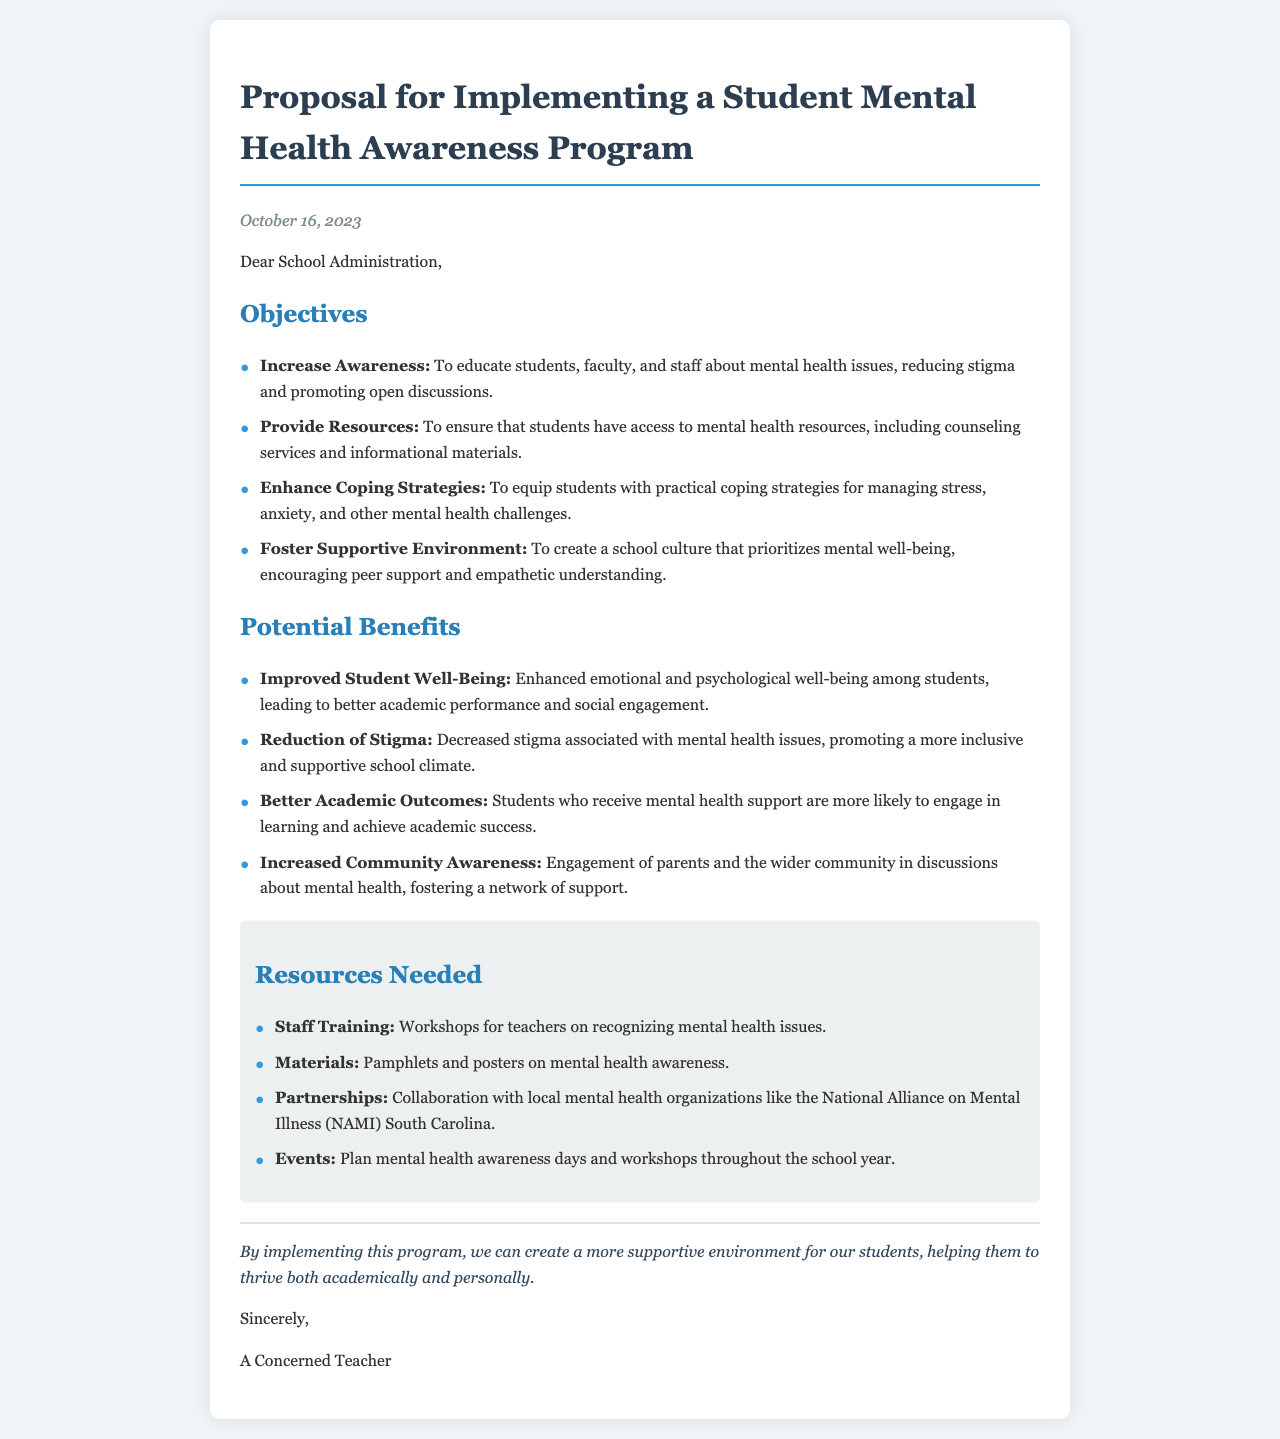what is the date of the proposal? The date of the proposal is stated in the document as the date it was written, which is October 16, 2023.
Answer: October 16, 2023 who is the letter addressed to? The letter is addressed to the School Administration, as indicated in the salutation of the document.
Answer: School Administration how many objectives are listed in the proposal? The proposal outlines four specific objectives, detailed in the section about the objectives.
Answer: Four what is one of the potential benefits of the program? A potential benefit listed in the document is improved emotional and psychological well-being among students, as elaborated under the potential benefits section.
Answer: Improved Student Well-Being what type of training is needed according to the resources section? The resources section specifies that staff training is one of the resources needed for the implementation of the program.
Answer: Staff Training what organization is mentioned for collaboration in the proposal? The document mentions collaborating with the National Alliance on Mental Illness (NAMI) South Carolina in the resources needed for the program.
Answer: NAMI South Carolina what is the concluding statement of the proposal? The conclusion summarizes the overall intent of the program and the hoped outcomes, which is a more supportive environment for students.
Answer: By implementing this program, we can create a more supportive environment for our students what category does "Enhance Coping Strategies" fall under in the proposal? "Enhance Coping Strategies" is categorized under objectives as one of the main goals of the mental health awareness program.
Answer: Objectives how is the document formatted visually? The document is structured with headings, subsections, lists, and emphasis on key points, which aids in readability.
Answer: Structured with headings and lists 